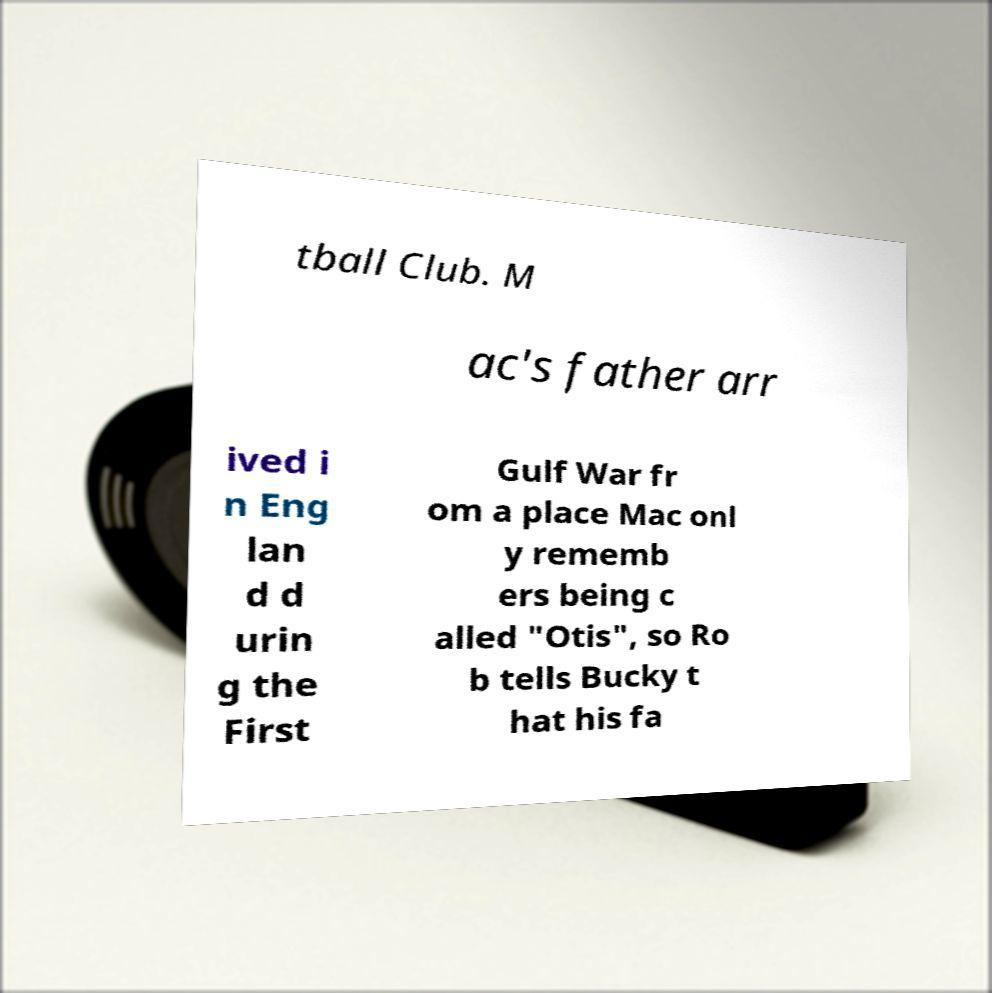I need the written content from this picture converted into text. Can you do that? tball Club. M ac's father arr ived i n Eng lan d d urin g the First Gulf War fr om a place Mac onl y rememb ers being c alled "Otis", so Ro b tells Bucky t hat his fa 